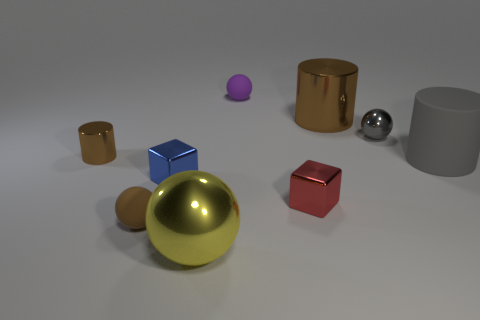How many matte things are the same color as the small metallic cylinder?
Your answer should be compact. 1. There is a small sphere that is in front of the gray cylinder; is there a small cylinder that is behind it?
Offer a terse response. Yes. Do the tiny matte sphere behind the red metal object and the rubber object in front of the large gray object have the same color?
Give a very brief answer. No. What is the color of the shiny cylinder that is the same size as the brown rubber object?
Ensure brevity in your answer.  Brown. Is the number of large gray cylinders behind the big gray cylinder the same as the number of large brown cylinders behind the small purple ball?
Give a very brief answer. Yes. What material is the large brown cylinder that is on the right side of the matte sphere behind the tiny blue metallic cube?
Provide a short and direct response. Metal. What number of objects are either brown rubber cubes or tiny matte objects?
Offer a very short reply. 2. What is the size of the shiny object that is the same color as the rubber cylinder?
Offer a very short reply. Small. Is the number of brown cylinders less than the number of matte cylinders?
Provide a short and direct response. No. There is a yellow thing that is made of the same material as the small gray sphere; what size is it?
Offer a very short reply. Large. 